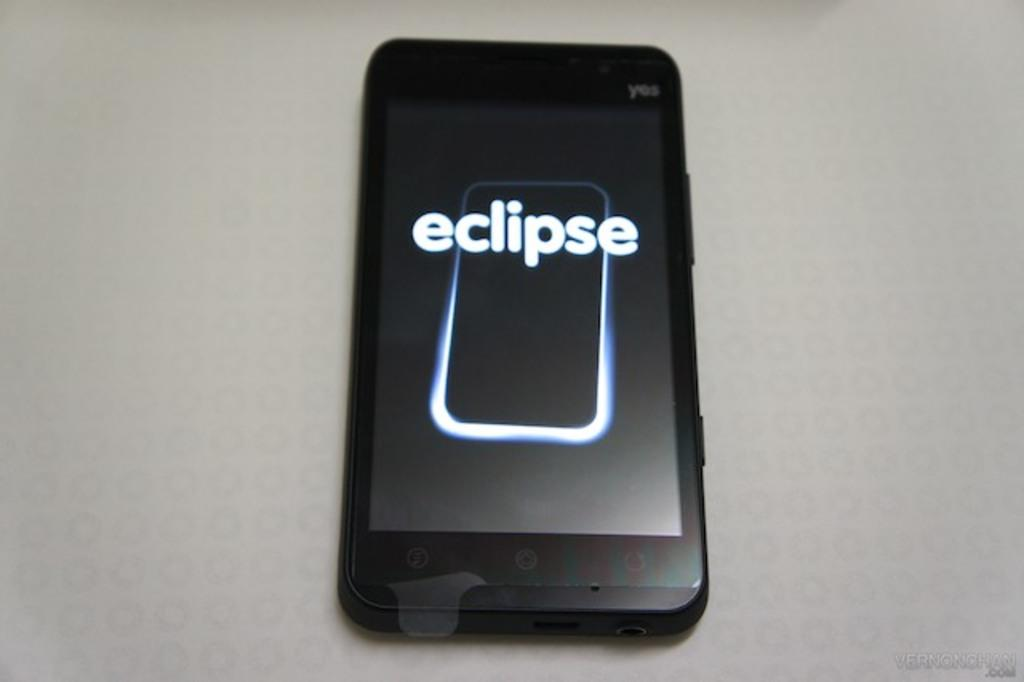<image>
Create a compact narrative representing the image presented. A black cellphone with an outline of a cellphone on the screen and the word eclipse. 